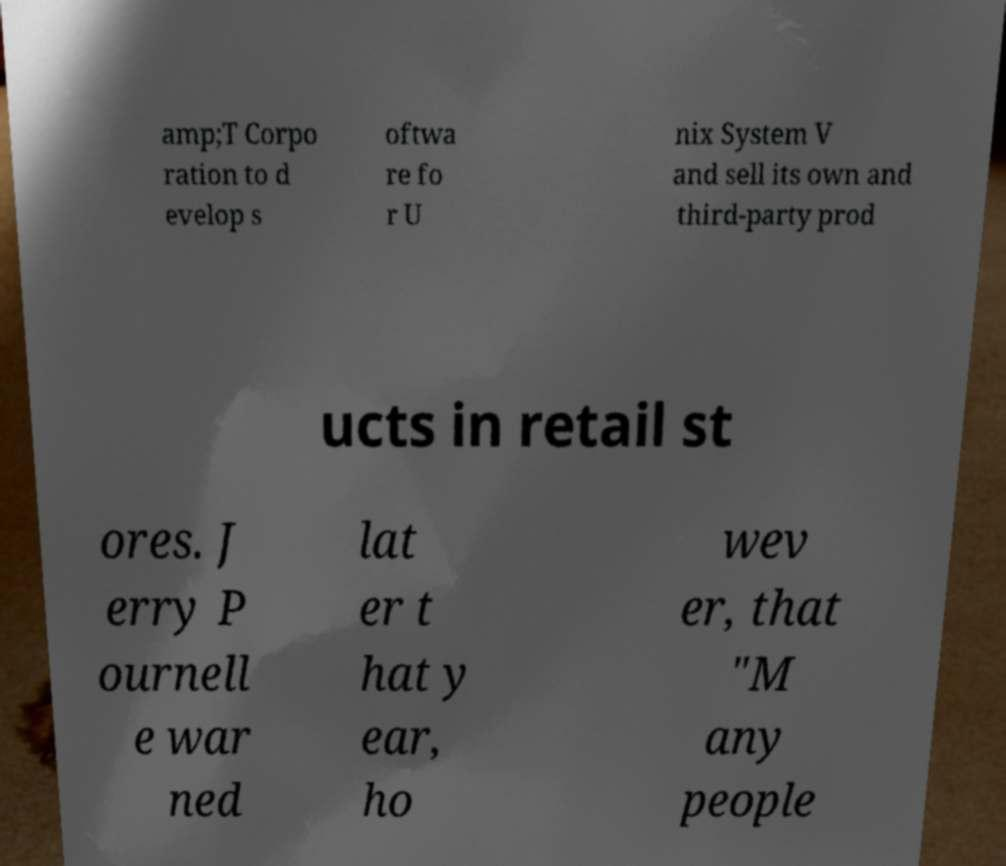There's text embedded in this image that I need extracted. Can you transcribe it verbatim? amp;T Corpo ration to d evelop s oftwa re fo r U nix System V and sell its own and third-party prod ucts in retail st ores. J erry P ournell e war ned lat er t hat y ear, ho wev er, that "M any people 